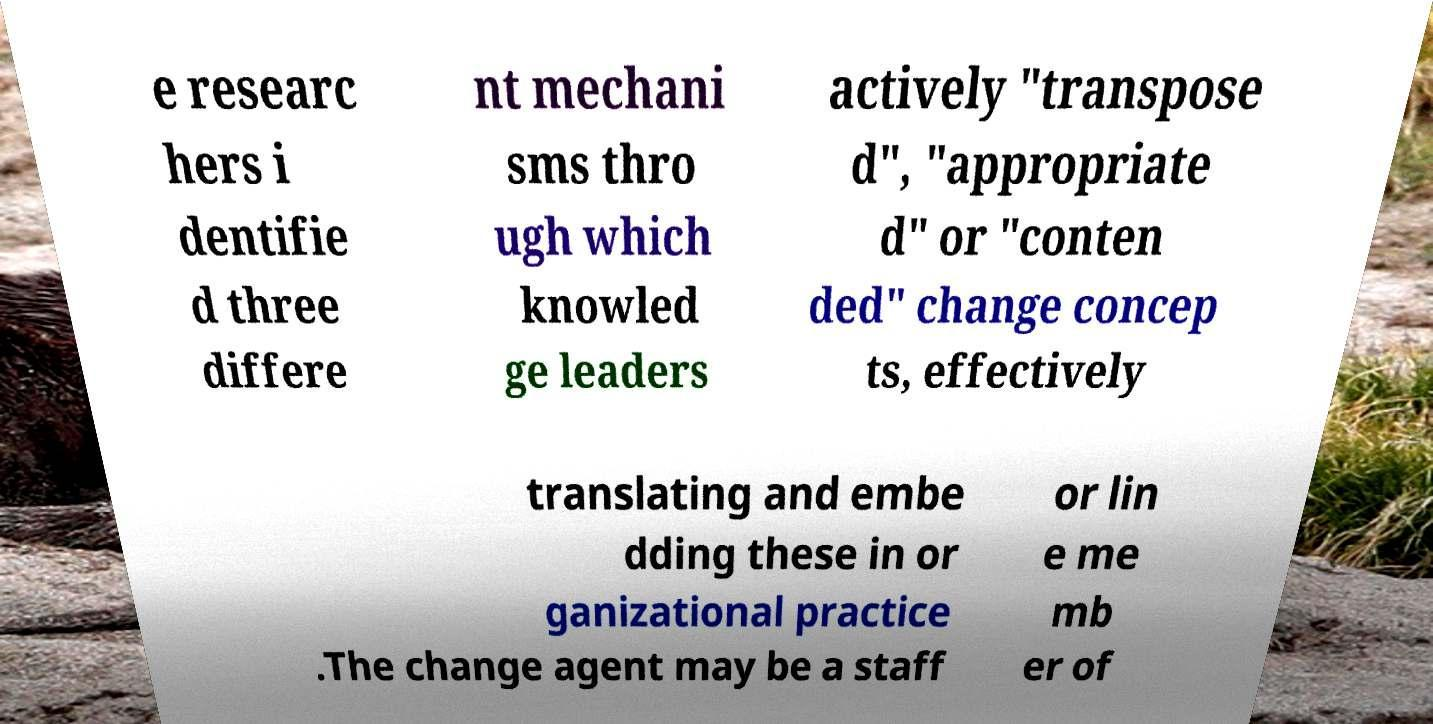Please identify and transcribe the text found in this image. e researc hers i dentifie d three differe nt mechani sms thro ugh which knowled ge leaders actively "transpose d", "appropriate d" or "conten ded" change concep ts, effectively translating and embe dding these in or ganizational practice .The change agent may be a staff or lin e me mb er of 